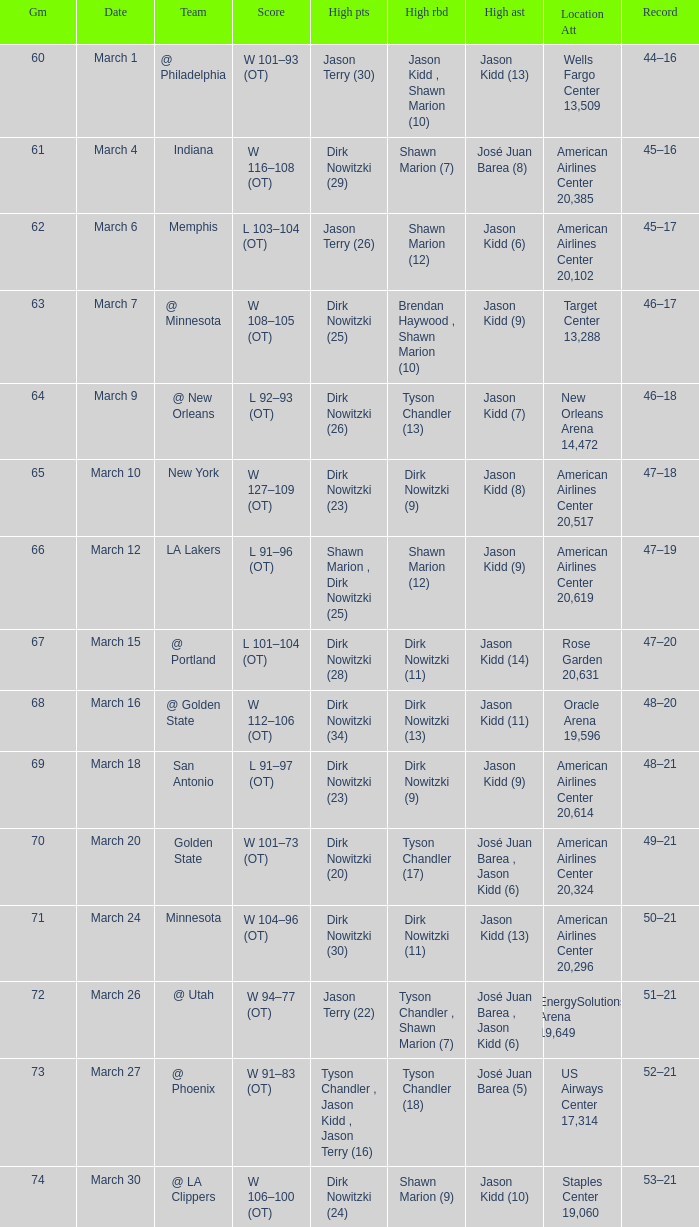Name the high points for march 30 Dirk Nowitzki (24). 